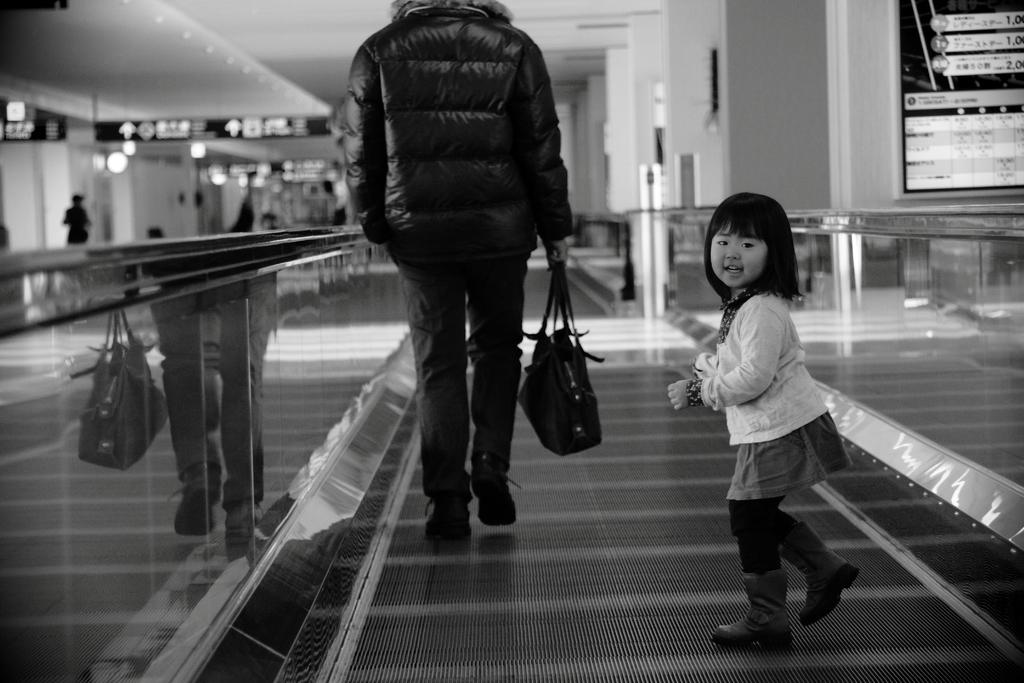Who is the main subject in the image? There is a girl in the image. What is the girl doing in the image? The girl is on the floor. Who else is present in the image? There is a person holding a bag in the image. What is the person holding the bag doing? The person holding the bag is also on the floor. Can you describe the background of the image? The background is blurry and includes a person, the ceiling, lights, and some objects. What type of meat is being served at the feast in the image? There is no feast or meat present in the image. What button is the girl pressing in the image? There is no button visible in the image. 